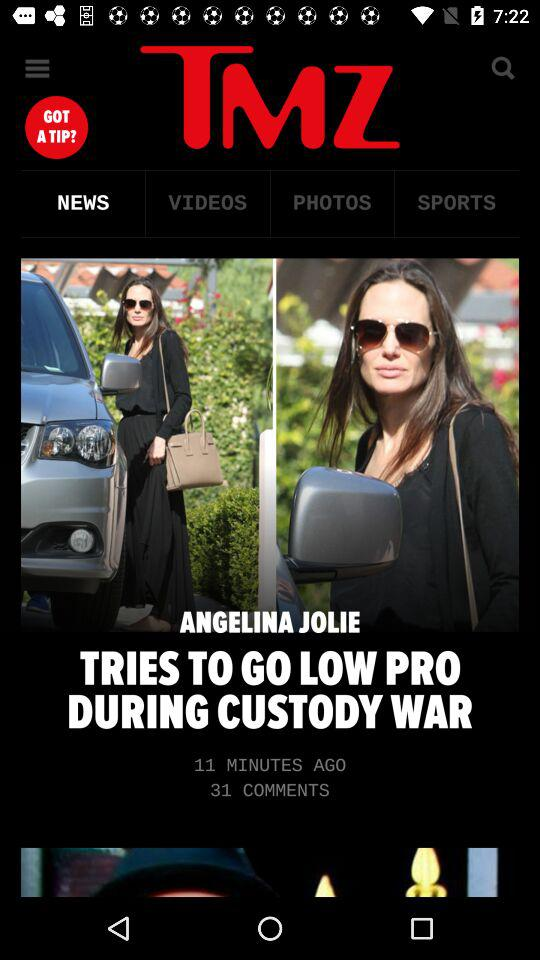When was Angelina Jolie's news posted? Angelina Jolie's news was posted 11 minutes ago. 